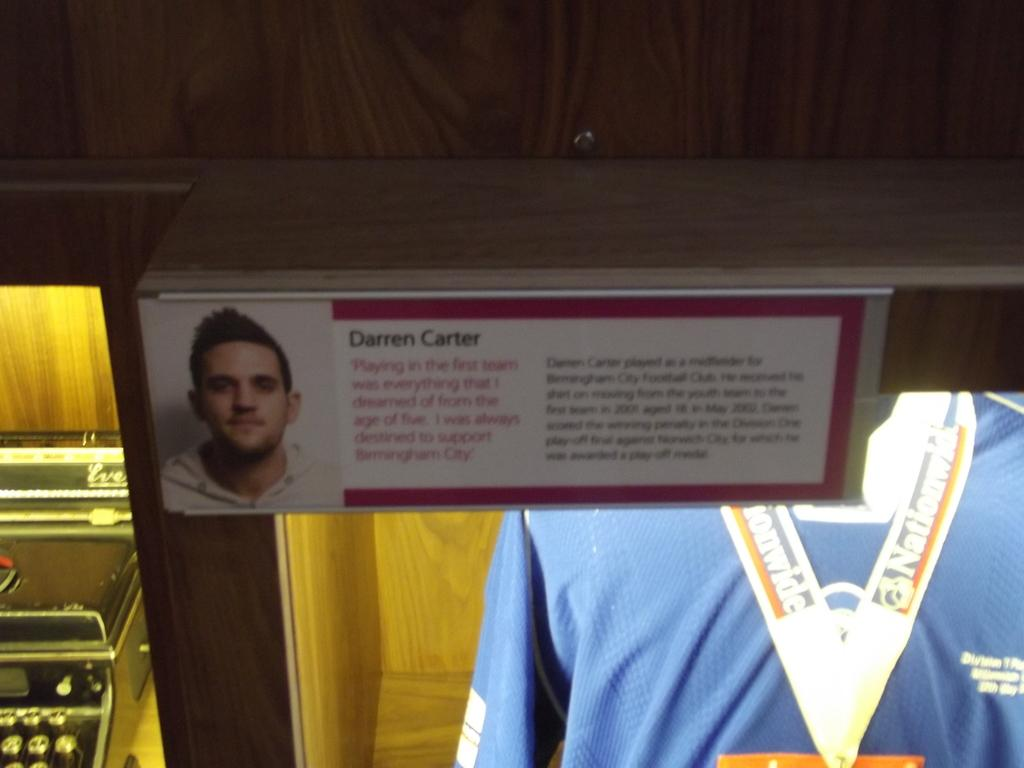Provide a one-sentence caption for the provided image. A wood case with Darren Carter's jersey in it. 